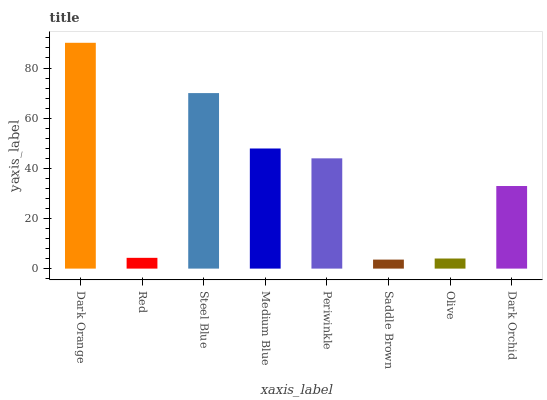Is Red the minimum?
Answer yes or no. No. Is Red the maximum?
Answer yes or no. No. Is Dark Orange greater than Red?
Answer yes or no. Yes. Is Red less than Dark Orange?
Answer yes or no. Yes. Is Red greater than Dark Orange?
Answer yes or no. No. Is Dark Orange less than Red?
Answer yes or no. No. Is Periwinkle the high median?
Answer yes or no. Yes. Is Dark Orchid the low median?
Answer yes or no. Yes. Is Medium Blue the high median?
Answer yes or no. No. Is Periwinkle the low median?
Answer yes or no. No. 